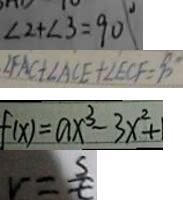<formula> <loc_0><loc_0><loc_500><loc_500>\angle 2 + \angle 3 = 9 0 ^ { \circ } 
 \angle F A C + \angle A C E + \angle E C F = 9 0 ^ { \circ } 
 f ( x ) = a x ^ { 3 } - 3 x ^ { 2 } + 1 
 v = \frac { s } { t }</formula> 